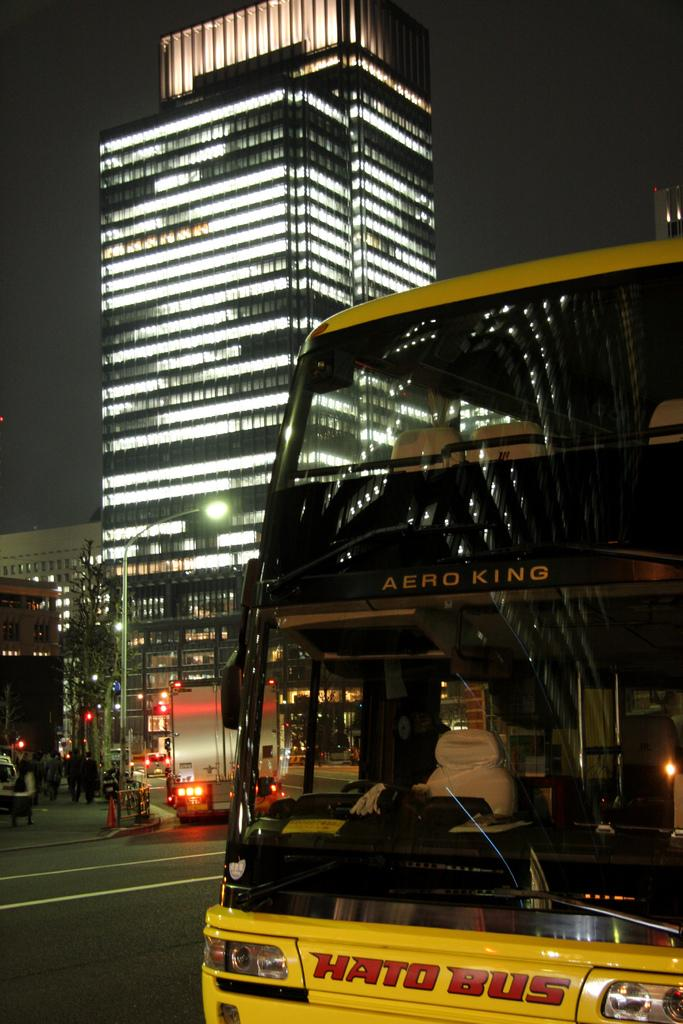Provide a one-sentence caption for the provided image. A yellow Hato Bus made by Aero King on a city street at night. 